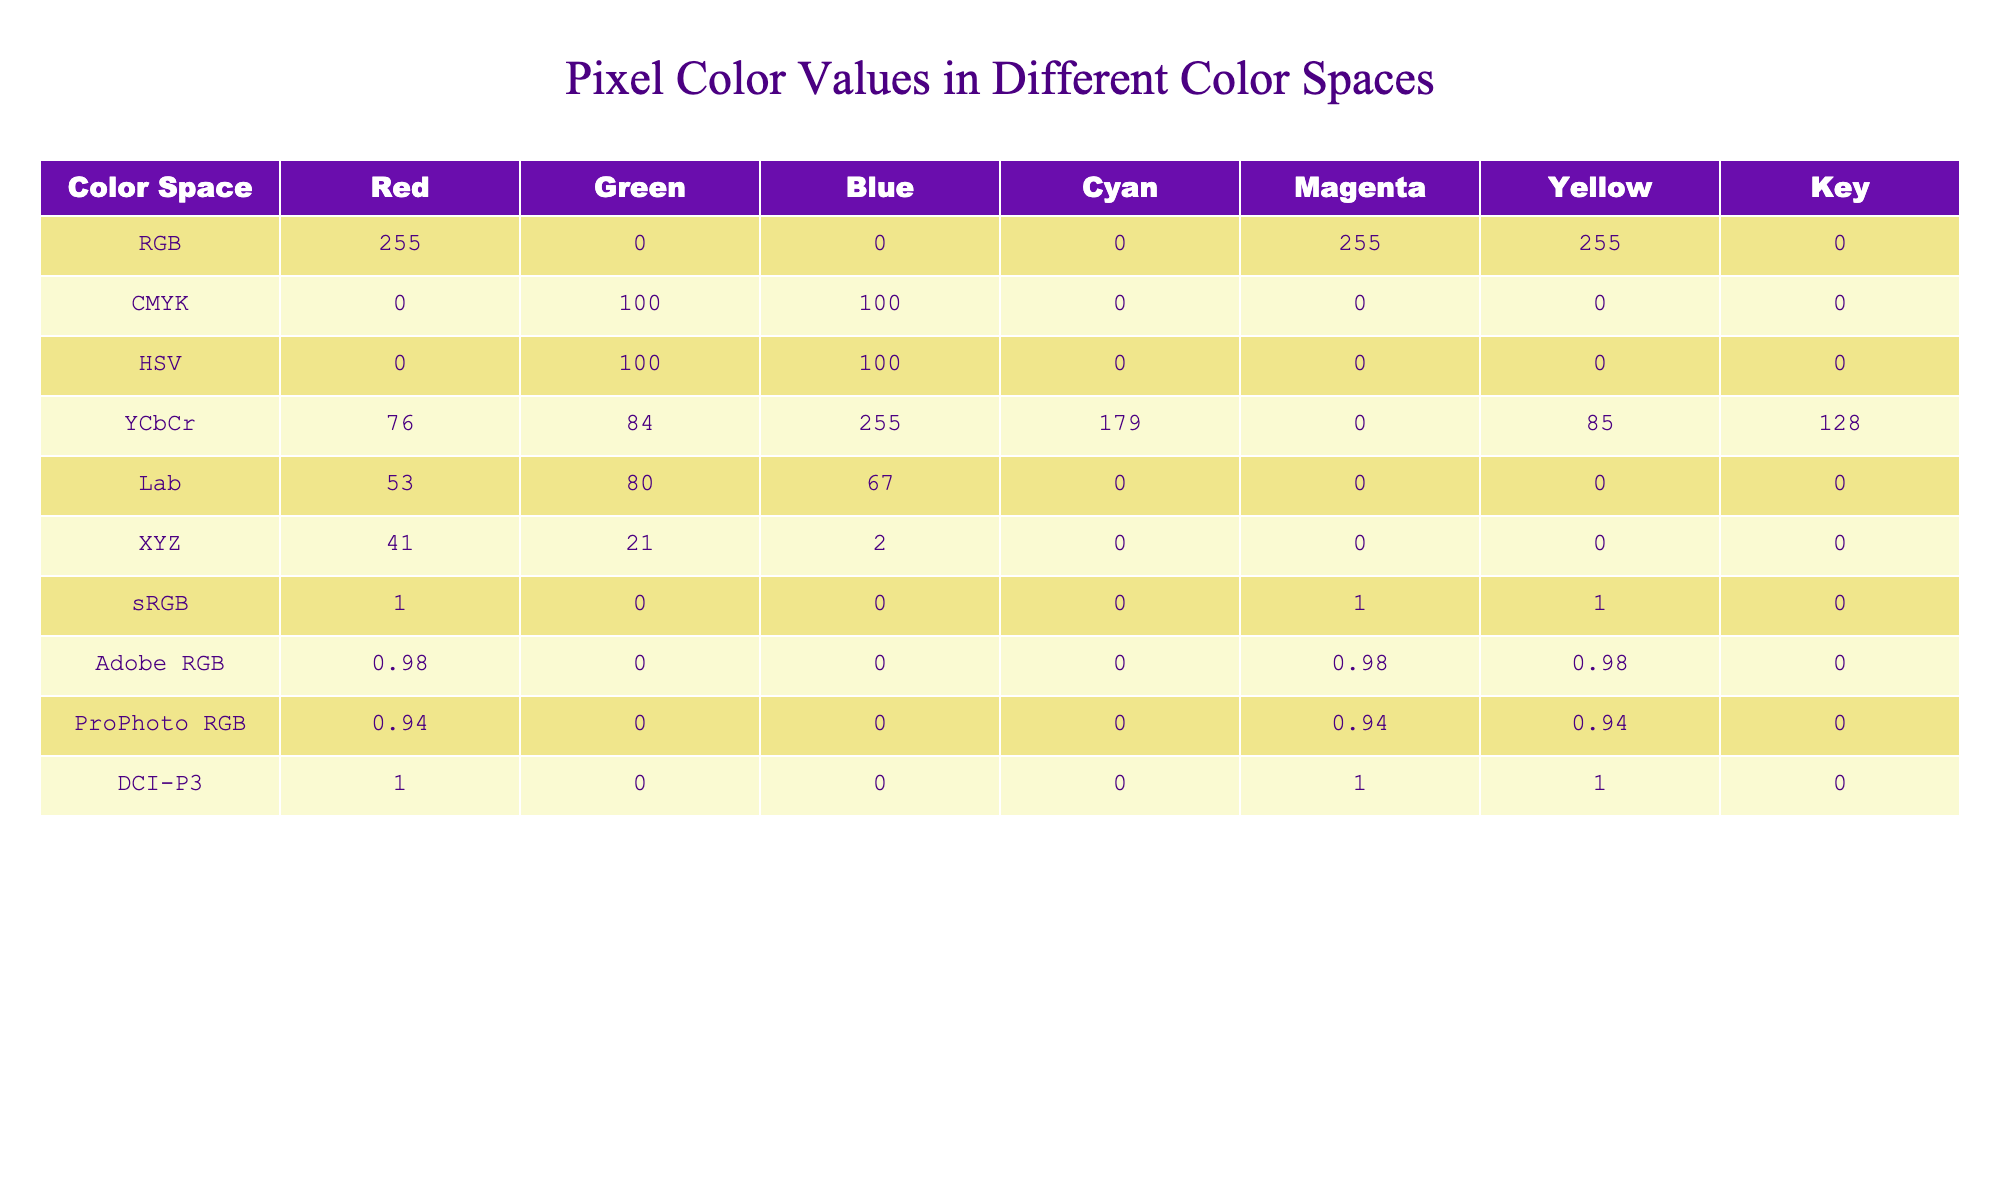What color space has the highest red value? The table shows the RGB color space with a red value of 255, which is the highest among all color spaces listed.
Answer: RGB What is the green value in the CMYK color space? The CMYK color space has a green value of 100, as indicated in the table.
Answer: 100 Which color space has the lowest blue value? The XYZ color space has the lowest blue value of 2, which is the smallest value in that column.
Answer: XYZ What are the RGB values of the DCI-P3 color space? In the DCI-P3 color space, the RGB values are 1.0 for red, 0.0 for green, and 0.0 for blue, according to the table.
Answer: (1.0, 0.0, 0.0) Is the value for yellow in the Lab color space greater than the value for yellow in the RGB color space? The yellow value in the Lab color space is 0, while in the RGB color space it is 255, so the statement is false.
Answer: No What is the average red value of the RGB and ProPhoto RGB color spaces? The red values for RGB and ProPhoto RGB are 255 and 0.94 respectively. The average is (255 + 0.94) / 2 = 127.97.
Answer: 127.97 Which color space has the highest cyan value, and what is it? The color spaces listed are compared, and the CMYK color space has a cyan value of 0, which is highest among the other color spaces that have a cyan value of 0.
Answer: CMYK (0) What is the sum of the green values across all color spaces? Adding all the green values: 0 + 100 + 100 + 84 + 80 + 21 + 0.0 + 0.0 + 0.0 + 0.0 = 385.
Answer: 385 In how many color spaces does the Key value equal zero? The table shows that the Key value is zero in CMYK, HSV, Lab, XYZ, sRGB, Adobe RGB, and ProPhoto RGB. That's a total of 7 color spaces.
Answer: 7 If we only consider the sRGB color space, what is its corresponding yellow value? The sRGB color space has a yellow value of 1.0, as shown in the table.
Answer: 1.0 